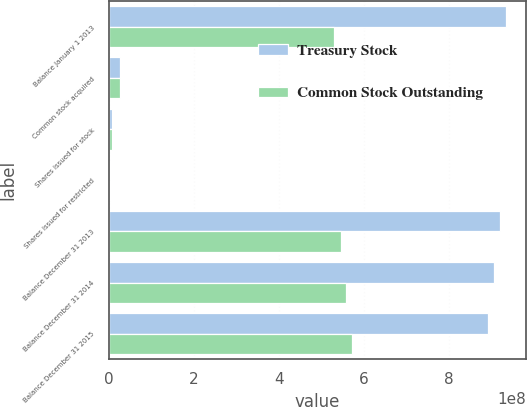<chart> <loc_0><loc_0><loc_500><loc_500><stacked_bar_chart><ecel><fcel>Balance January 1 2013<fcel>Common stock acquired<fcel>Shares issued for stock<fcel>Shares issued for restricted<fcel>Balance December 31 2013<fcel>Balance December 31 2014<fcel>Balance December 31 2015<nl><fcel>Treasury Stock<fcel>9.35729e+08<fcel>2.55733e+07<fcel>7.88383e+06<fcel>1.90738e+06<fcel>9.19947e+08<fcel>9.06712e+08<fcel>8.92739e+08<nl><fcel>Common Stock Outstanding<fcel>5.29978e+08<fcel>2.55733e+07<fcel>7.88383e+06<fcel>1.90738e+06<fcel>5.4576e+08<fcel>5.58994e+08<fcel>5.72968e+08<nl></chart> 